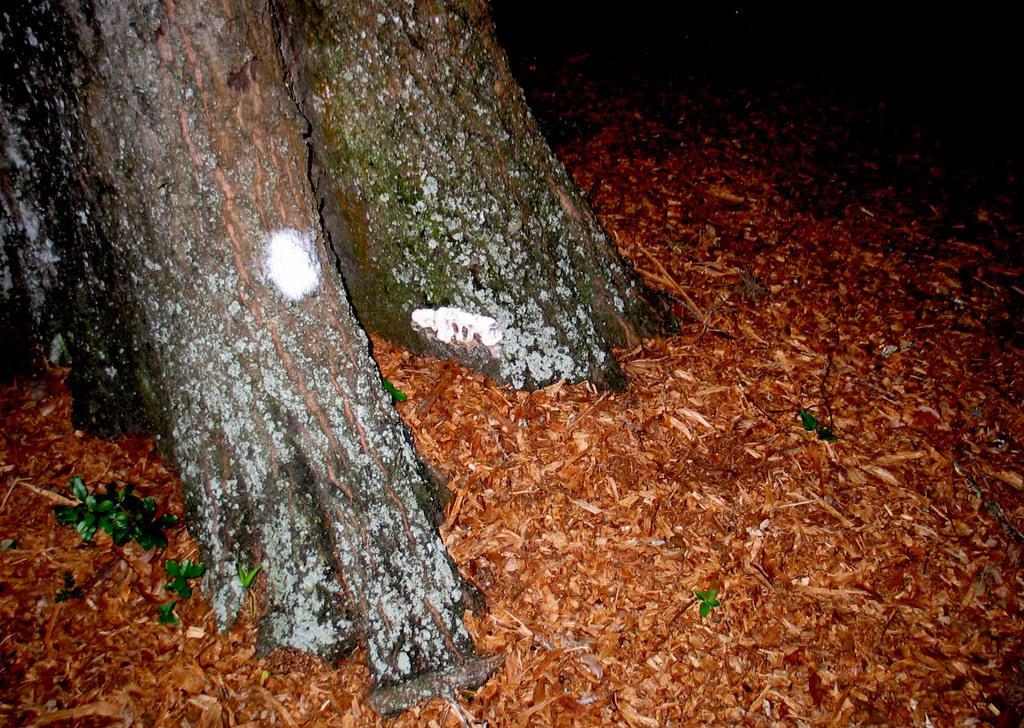In one or two sentences, can you explain what this image depicts? On the left side these are the trees and here this is the wooden powder. 